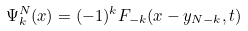Convert formula to latex. <formula><loc_0><loc_0><loc_500><loc_500>\Psi _ { k } ^ { N } ( x ) = ( - 1 ) ^ { k } F _ { - k } ( x - y _ { N - k } , t )</formula> 